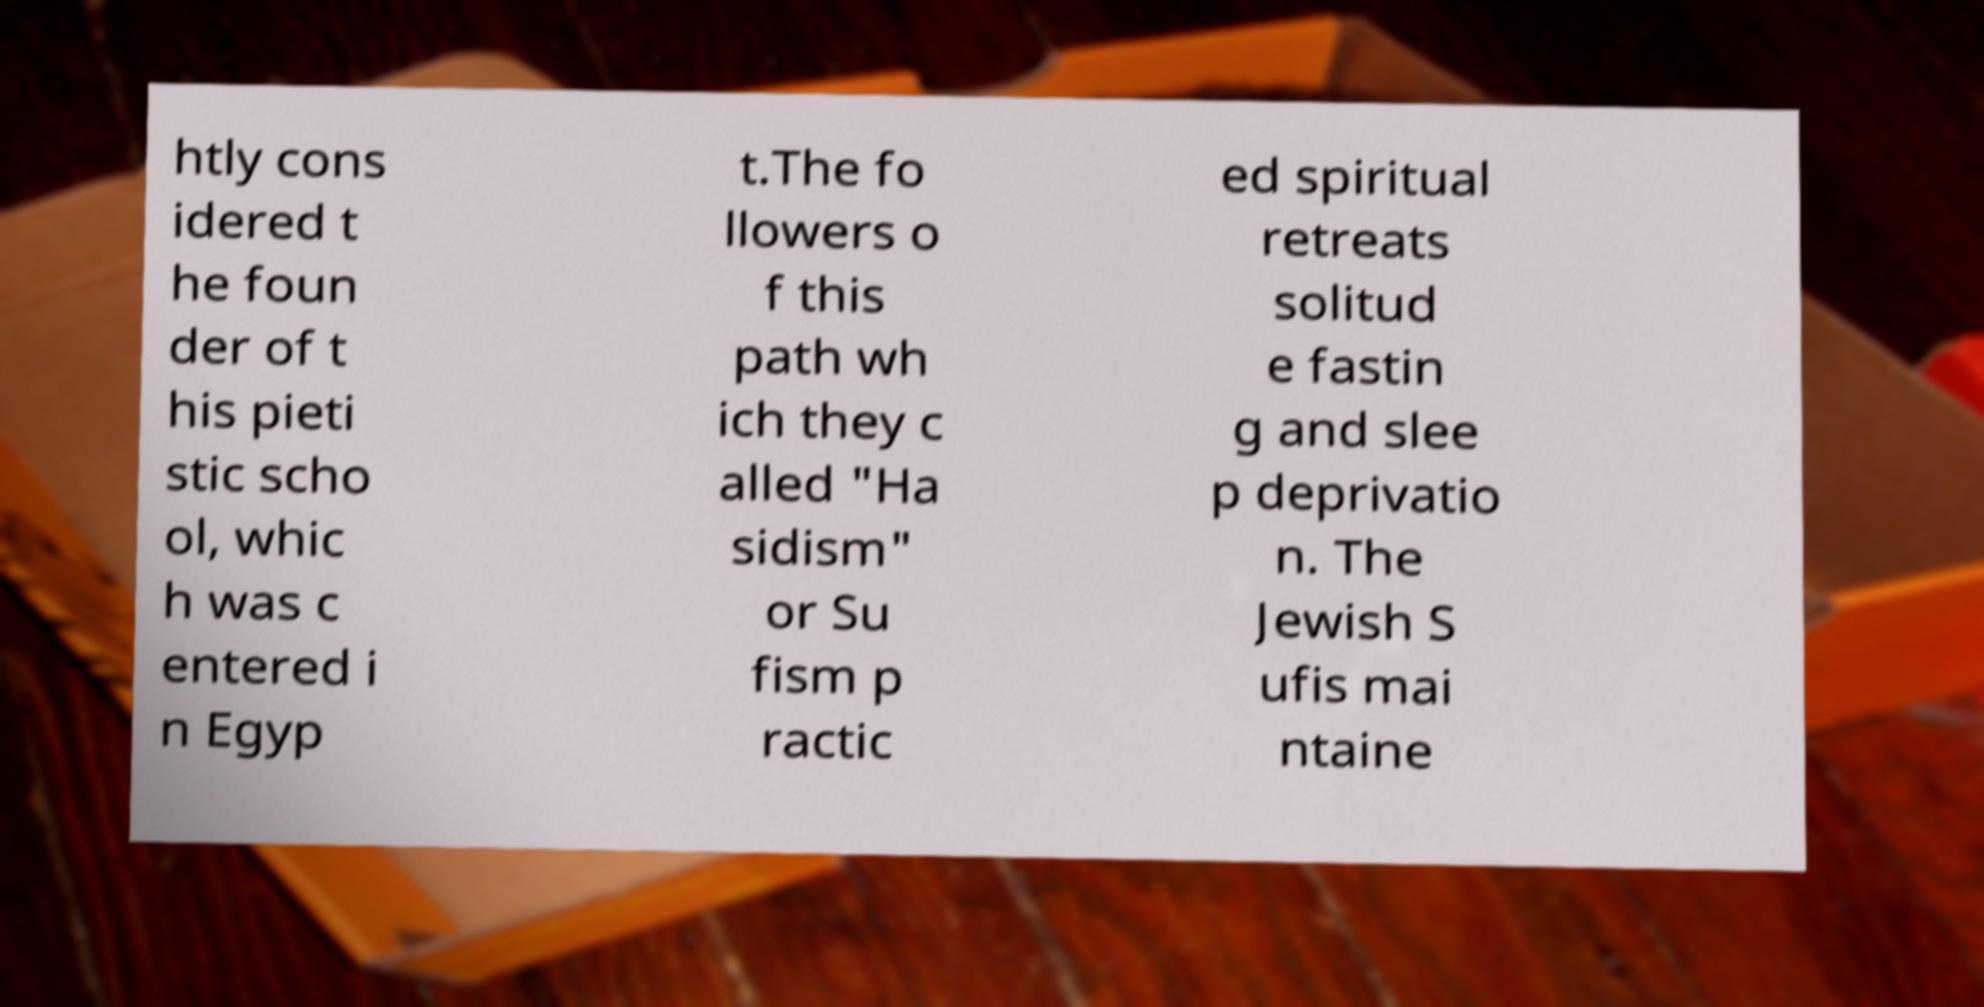Could you extract and type out the text from this image? htly cons idered t he foun der of t his pieti stic scho ol, whic h was c entered i n Egyp t.The fo llowers o f this path wh ich they c alled "Ha sidism" or Su fism p ractic ed spiritual retreats solitud e fastin g and slee p deprivatio n. The Jewish S ufis mai ntaine 